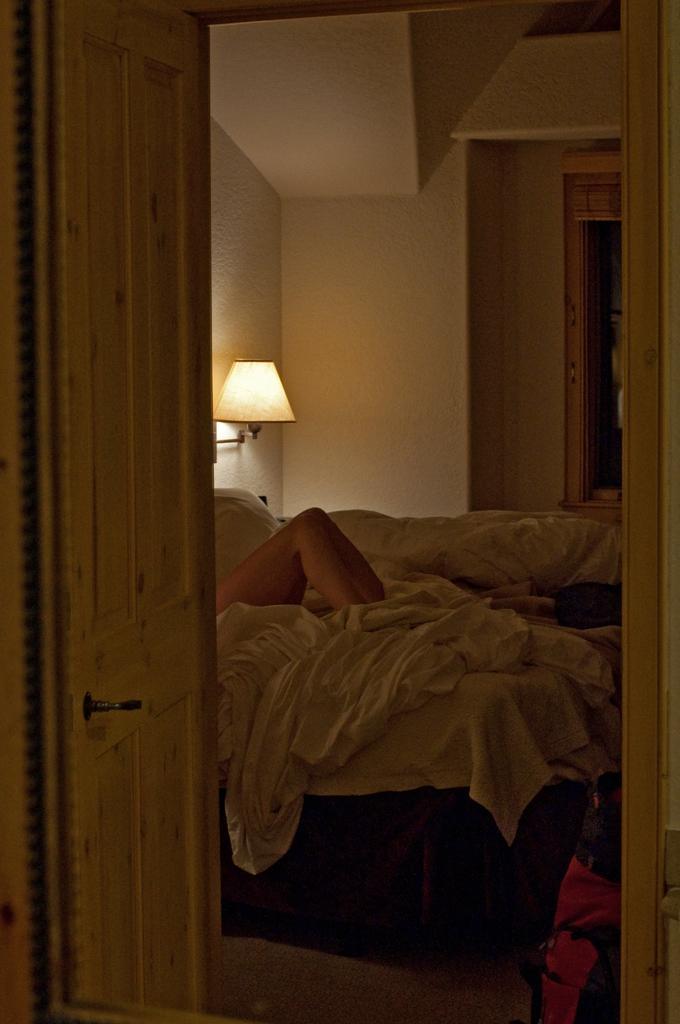In one or two sentences, can you explain what this image depicts? In this picture we can see a door. We can see a person's legs on a bed. We can see blankets, light and few objects. 